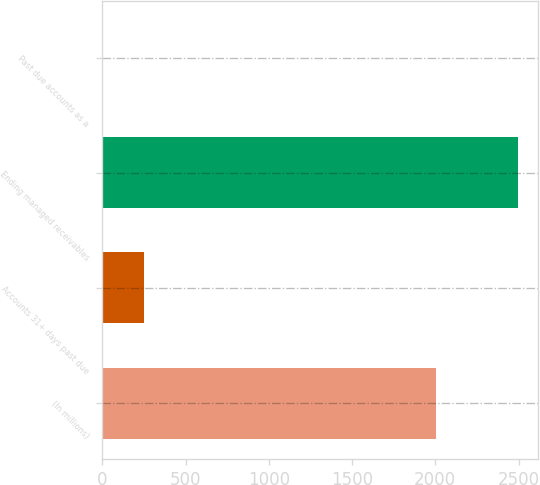Convert chart. <chart><loc_0><loc_0><loc_500><loc_500><bar_chart><fcel>(In millions)<fcel>Accounts 31+ days past due<fcel>Ending managed receivables<fcel>Past due accounts as a<nl><fcel>2005<fcel>250.61<fcel>2494.9<fcel>1.24<nl></chart> 